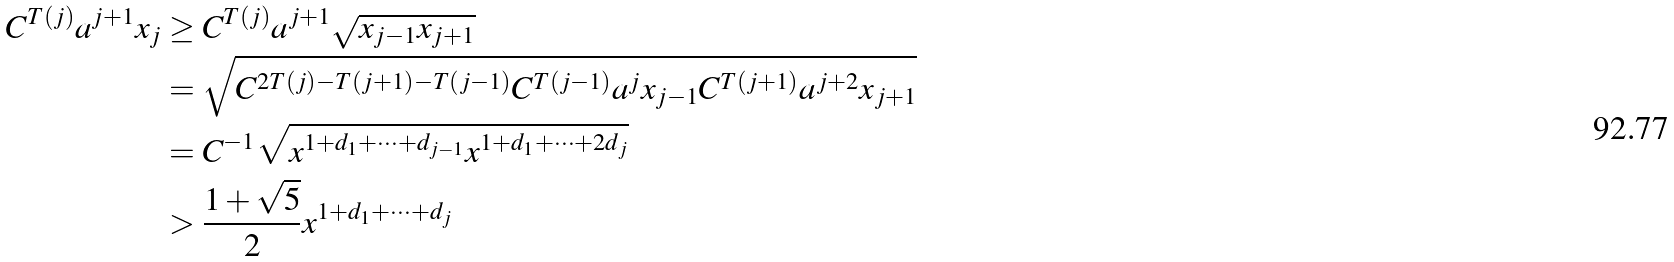<formula> <loc_0><loc_0><loc_500><loc_500>C ^ { T ( j ) } a ^ { j + 1 } x _ { j } & \geq C ^ { T ( j ) } a ^ { j + 1 } \sqrt { x _ { j - 1 } x _ { j + 1 } } \\ & = \sqrt { C ^ { 2 T ( j ) - T ( j + 1 ) - T ( j - 1 ) } C ^ { T ( j - 1 ) } a ^ { j } x _ { j - 1 } C ^ { T ( j + 1 ) } a ^ { j + 2 } x _ { j + 1 } } \\ & = C ^ { - 1 } \sqrt { x ^ { 1 + d _ { 1 } + \cdots + d _ { j - 1 } } x ^ { 1 + d _ { 1 } + \cdots + 2 d _ { j } } } \\ & > \frac { 1 + \sqrt { 5 } } { 2 } x ^ { 1 + d _ { 1 } + \cdots + d _ { j } }</formula> 